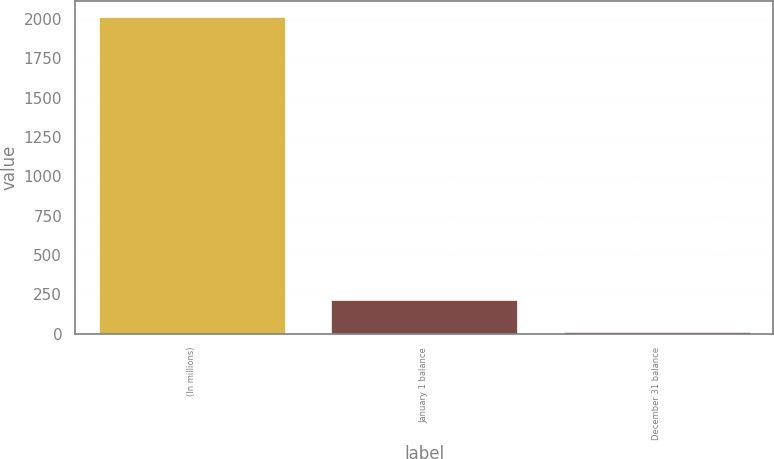<chart> <loc_0><loc_0><loc_500><loc_500><bar_chart><fcel>(In millions)<fcel>January 1 balance<fcel>December 31 balance<nl><fcel>2013<fcel>213<fcel>13<nl></chart> 